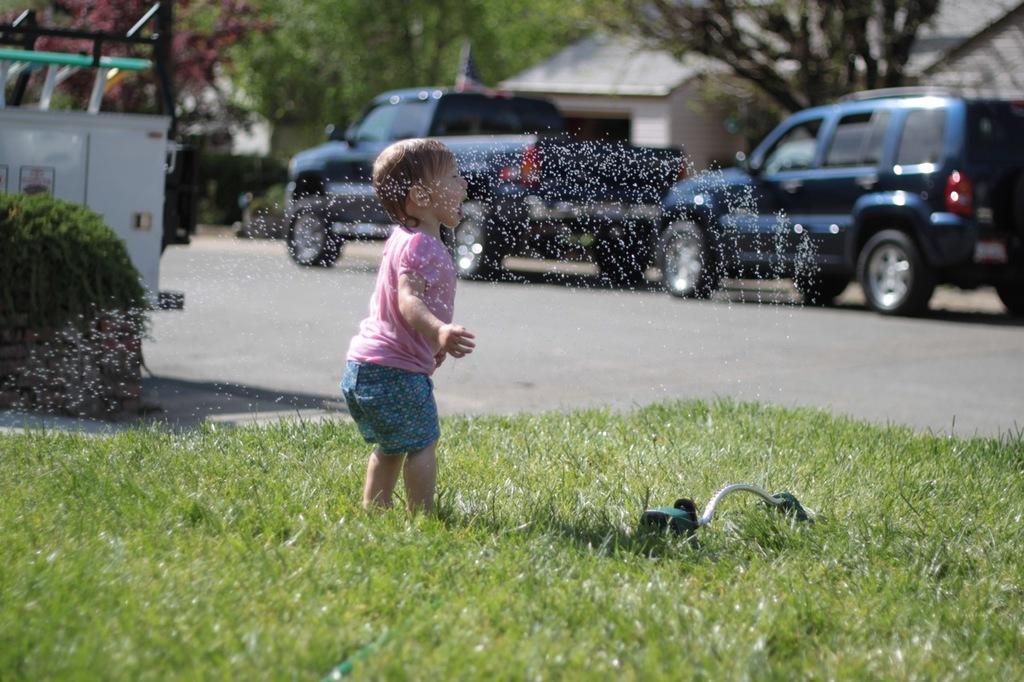How would you summarize this image in a sentence or two? In this image we can see a kid and an object on the grass and there are few vehicles on the road and there are few trees and buildings in the background. 